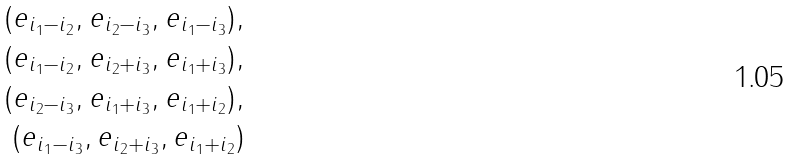Convert formula to latex. <formula><loc_0><loc_0><loc_500><loc_500>( e _ { i _ { 1 } - i _ { 2 } } , e _ { i _ { 2 } - i _ { 3 } } , e _ { i _ { 1 } - i _ { 3 } } ) , \\ ( e _ { i _ { 1 } - i _ { 2 } } , e _ { i _ { 2 } + i _ { 3 } } , e _ { i _ { 1 } + i _ { 3 } } ) , \\ ( e _ { i _ { 2 } - i _ { 3 } } , e _ { i _ { 1 } + i _ { 3 } } , e _ { i _ { 1 } + i _ { 2 } } ) , \\ ( e _ { i _ { 1 } - i _ { 3 } } , e _ { i _ { 2 } + i _ { 3 } } , e _ { i _ { 1 } + i _ { 2 } } )</formula> 